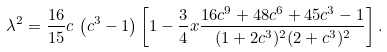<formula> <loc_0><loc_0><loc_500><loc_500>\lambda ^ { 2 } = \frac { 1 6 } { 1 5 } c \, \left ( c ^ { 3 } - 1 \right ) \left [ 1 - \frac { 3 } { 4 } x \frac { 1 6 c ^ { 9 } + 4 8 c ^ { 6 } + 4 5 c ^ { 3 } - 1 } { ( 1 + 2 c ^ { 3 } ) ^ { 2 } ( 2 + c ^ { 3 } ) ^ { 2 } } \right ] .</formula> 